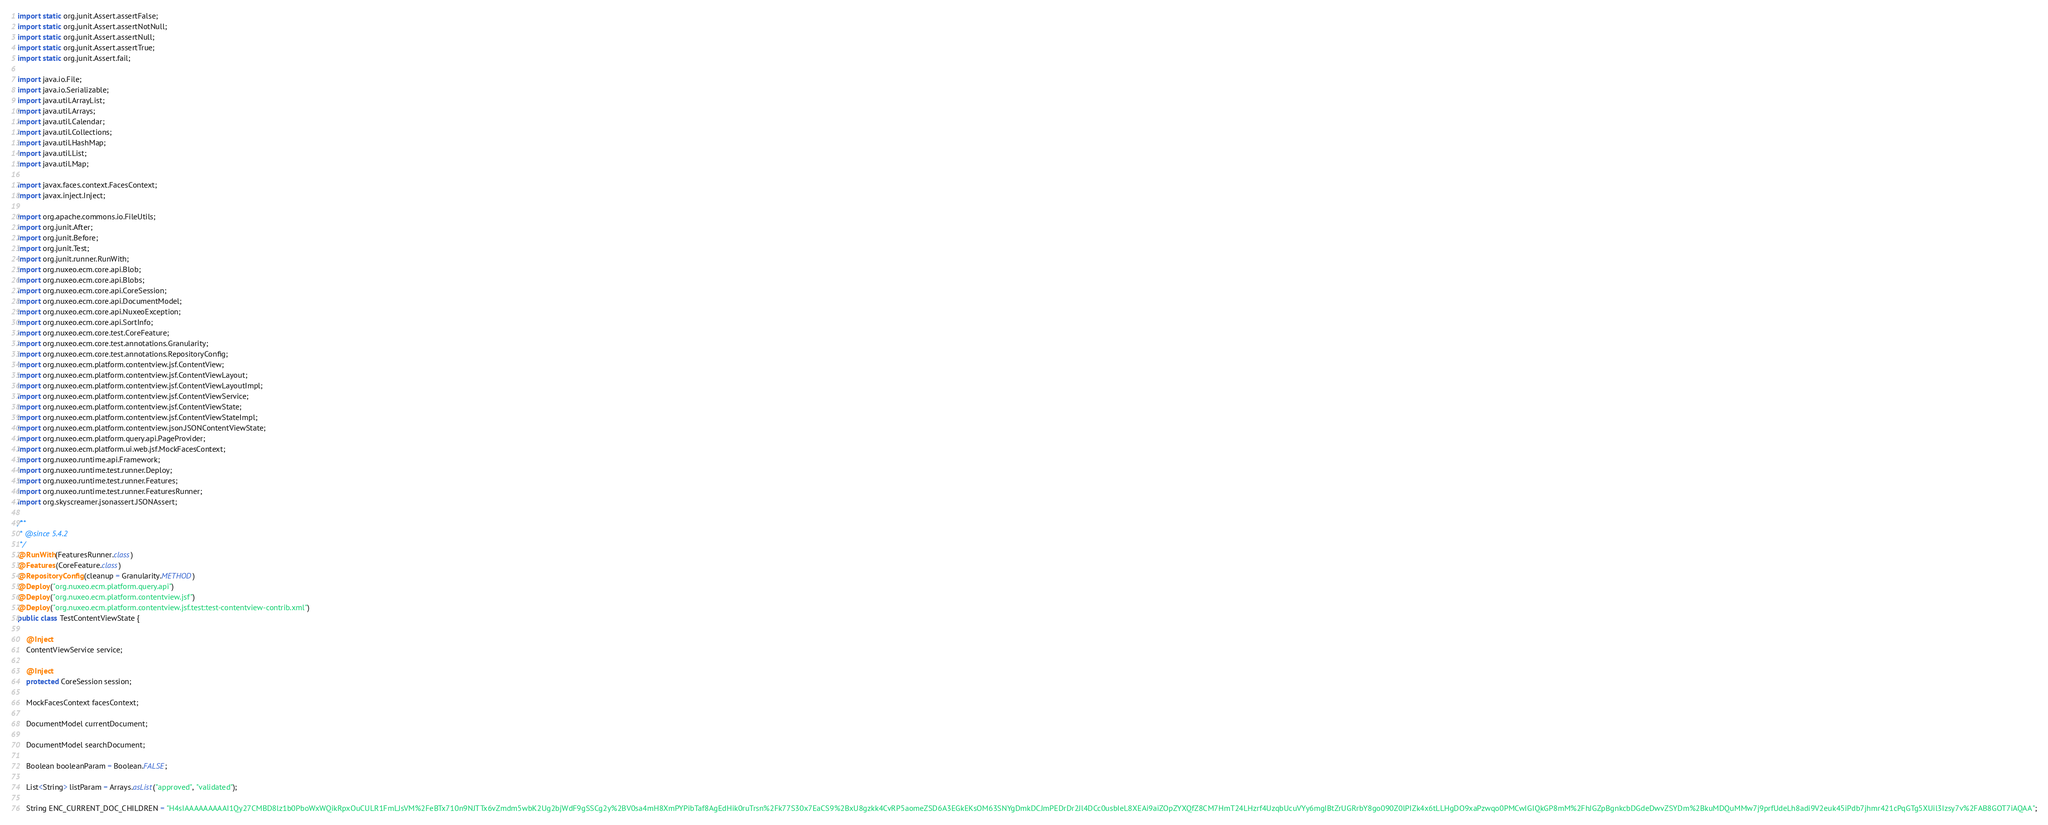Convert code to text. <code><loc_0><loc_0><loc_500><loc_500><_Java_>import static org.junit.Assert.assertFalse;
import static org.junit.Assert.assertNotNull;
import static org.junit.Assert.assertNull;
import static org.junit.Assert.assertTrue;
import static org.junit.Assert.fail;

import java.io.File;
import java.io.Serializable;
import java.util.ArrayList;
import java.util.Arrays;
import java.util.Calendar;
import java.util.Collections;
import java.util.HashMap;
import java.util.List;
import java.util.Map;

import javax.faces.context.FacesContext;
import javax.inject.Inject;

import org.apache.commons.io.FileUtils;
import org.junit.After;
import org.junit.Before;
import org.junit.Test;
import org.junit.runner.RunWith;
import org.nuxeo.ecm.core.api.Blob;
import org.nuxeo.ecm.core.api.Blobs;
import org.nuxeo.ecm.core.api.CoreSession;
import org.nuxeo.ecm.core.api.DocumentModel;
import org.nuxeo.ecm.core.api.NuxeoException;
import org.nuxeo.ecm.core.api.SortInfo;
import org.nuxeo.ecm.core.test.CoreFeature;
import org.nuxeo.ecm.core.test.annotations.Granularity;
import org.nuxeo.ecm.core.test.annotations.RepositoryConfig;
import org.nuxeo.ecm.platform.contentview.jsf.ContentView;
import org.nuxeo.ecm.platform.contentview.jsf.ContentViewLayout;
import org.nuxeo.ecm.platform.contentview.jsf.ContentViewLayoutImpl;
import org.nuxeo.ecm.platform.contentview.jsf.ContentViewService;
import org.nuxeo.ecm.platform.contentview.jsf.ContentViewState;
import org.nuxeo.ecm.platform.contentview.jsf.ContentViewStateImpl;
import org.nuxeo.ecm.platform.contentview.json.JSONContentViewState;
import org.nuxeo.ecm.platform.query.api.PageProvider;
import org.nuxeo.ecm.platform.ui.web.jsf.MockFacesContext;
import org.nuxeo.runtime.api.Framework;
import org.nuxeo.runtime.test.runner.Deploy;
import org.nuxeo.runtime.test.runner.Features;
import org.nuxeo.runtime.test.runner.FeaturesRunner;
import org.skyscreamer.jsonassert.JSONAssert;

/**
 * @since 5.4.2
 */
@RunWith(FeaturesRunner.class)
@Features(CoreFeature.class)
@RepositoryConfig(cleanup = Granularity.METHOD)
@Deploy("org.nuxeo.ecm.platform.query.api")
@Deploy("org.nuxeo.ecm.platform.contentview.jsf")
@Deploy("org.nuxeo.ecm.platform.contentview.jsf.test:test-contentview-contrib.xml")
public class TestContentViewState {

    @Inject
    ContentViewService service;

    @Inject
    protected CoreSession session;

    MockFacesContext facesContext;

    DocumentModel currentDocument;

    DocumentModel searchDocument;

    Boolean booleanParam = Boolean.FALSE;

    List<String> listParam = Arrays.asList("approved", "validated");

    String ENC_CURRENT_DOC_CHILDREN = "H4sIAAAAAAAAAI1Qy27CMBD8lz1b0PboWxWQikRpxOuCULR1FmLJsVM%2FeBTx710n9NJTTx6vZmdm5wbK2Ug2bjWdF9gSSCg2y%2BV0sa4mH8XmPYPibTaf8AgEdHik0ruTrsn%2Fk77S30x7EaCS9%2BxU8gzkk4CvRP5aomeZSD6A3EGkEKsOM63SNYgDmkDCJmPEDrDr2Jl4DCc0usbIeL8XEAi9aiZOpZYXQfZ8CM7HmT24LHzrf4UzqbUcuVYy6mgIBtZrUGRrbY8go090Z0lPIZk4x6tLLHgDO9xaPzwqo0PMCwIGIQkGP8mM%2FhJGZpBgnkcbDGdeDwvZSYDm%2BkuMDQuMMw7j9prfUdeLh8adi9V2euk45iPdb7jhmr421cPqGTg5XUil3Izsy7v%2FAB8GOT7iAQAA";
</code> 